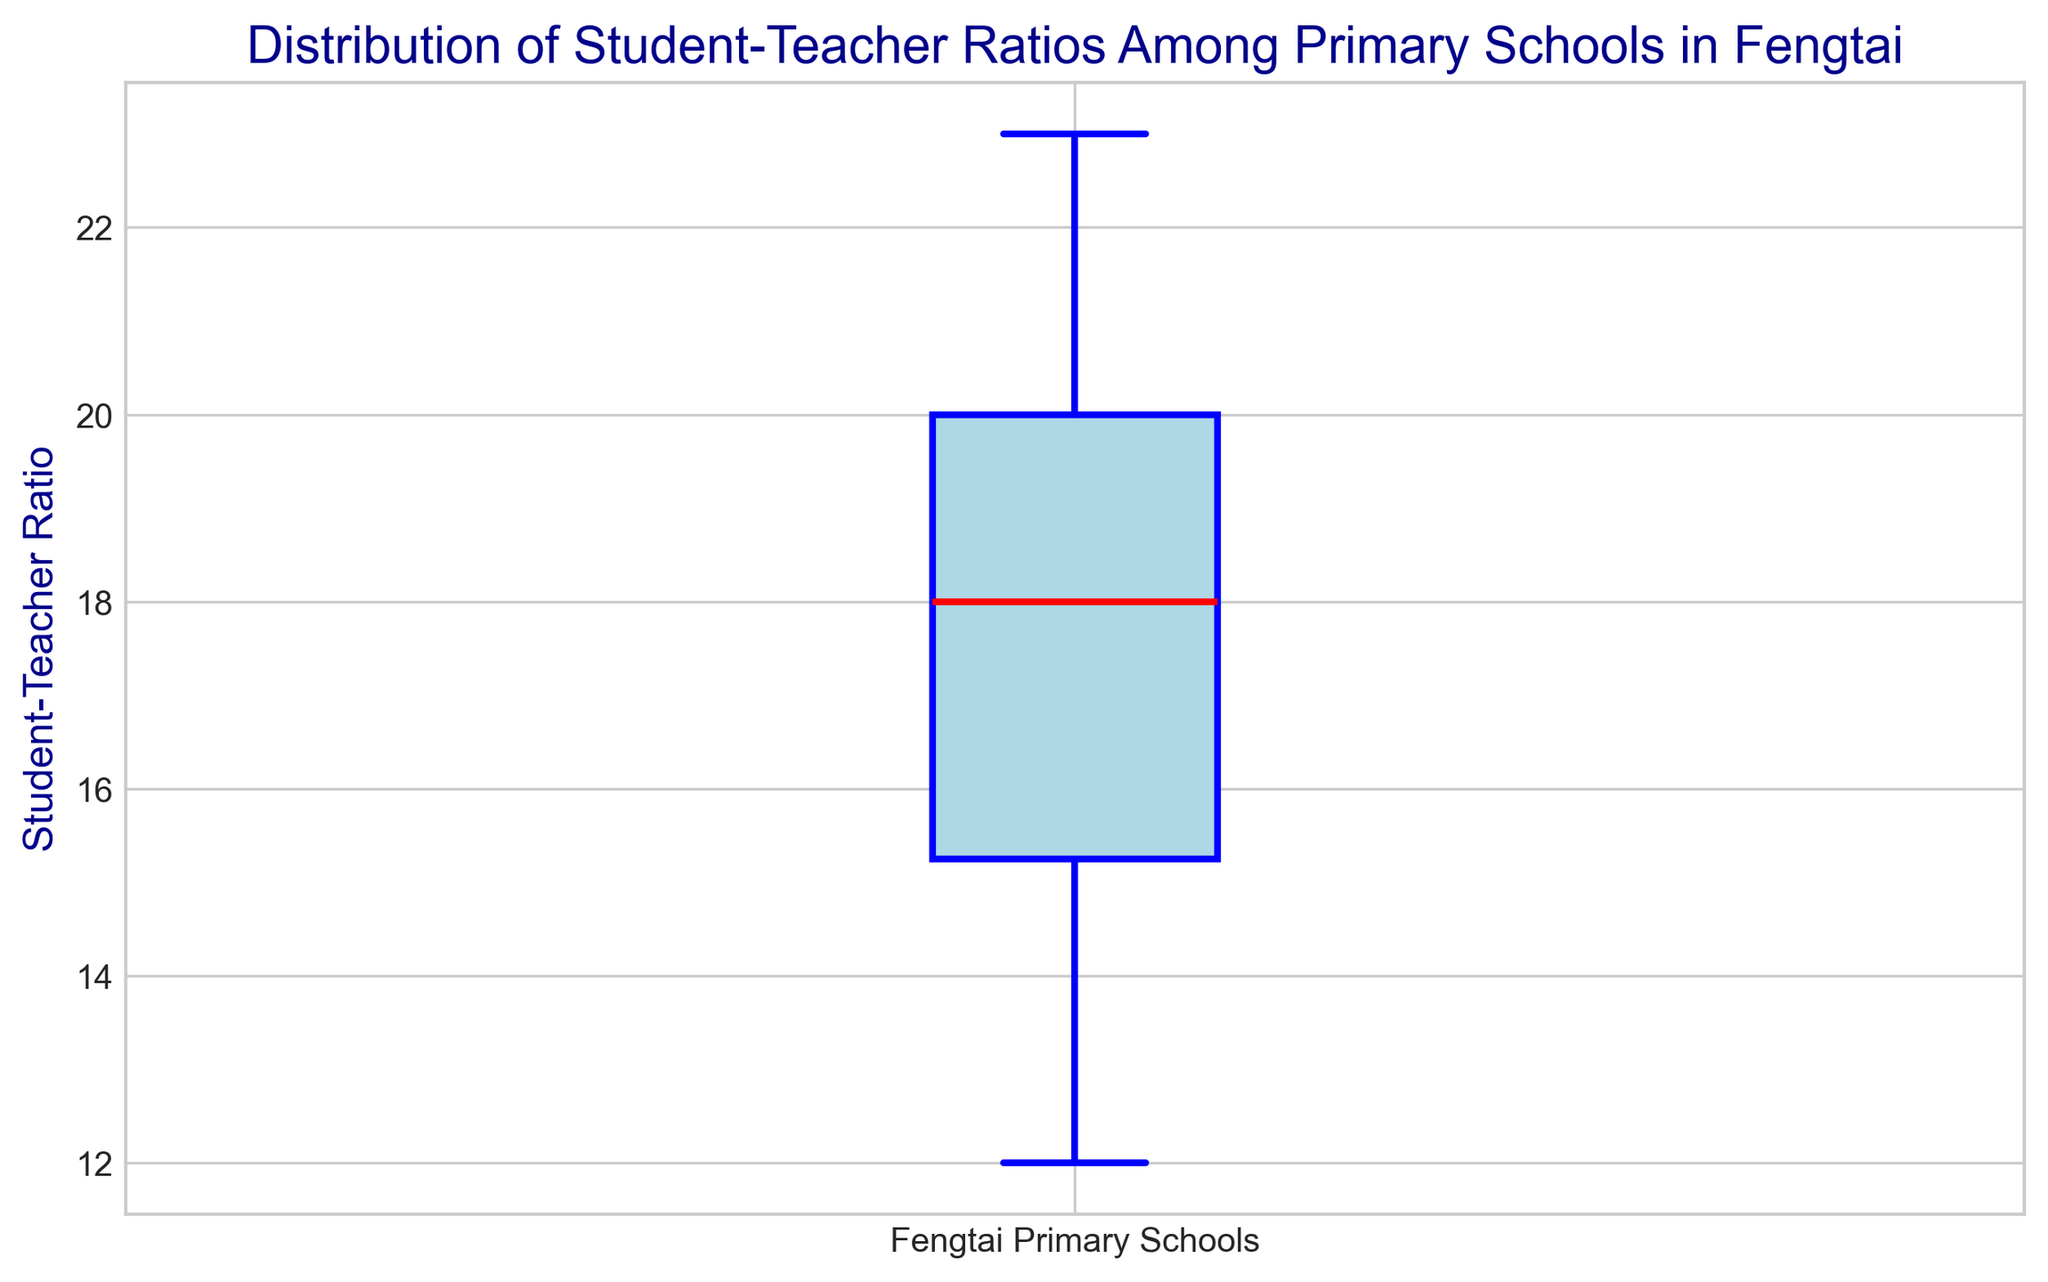What is the median student-teacher ratio in Fengtai primary schools according to the box plot? To find the median, locate the middle line of the box plot, which represents the median student-teacher ratio.
Answer: 18 What is the interquartile range (IQR) of the student-teacher ratios? The IQR is the difference between the third quartile (Q3) and the first quartile (Q1). From the box plot, Q3 is at 20 and Q1 is at 15. Thus, IQR = Q3 - Q1 = 20 - 15.
Answer: 5 What can you deduce about the spread of student-teacher ratios based on the length of the box? The length of the box represents the IQR, indicating the spread of the middle 50% of data. A longer box signifies a wider spread and more variability in the middle half of the student-teacher ratios.
Answer: Wide spread Which value(s) might be considered outliers in this distribution? Outliers are points that lie beyond the whiskers of the box plot. From the box plot, observe the points marked outside the whiskers, which are usually indicated by dots.
Answer: None visible Compare the median student-teacher ratio to the upper whisker. Is the upper whisker value higher than the median? Locate both the median (middle line within the box) and the upper whisker (top extent of the whiskers) on the box plot. The upper whisker value is higher than the median if it lies above the median's position.
Answer: Yes How can you identify the minimum student-teacher ratio in the distribution? The minimum student-teacher ratio corresponds to the bottom whisker of the box plot. Locate the bottom end of the whisker on the plot to find this value.
Answer: 12 Determine the range of student-teacher ratios shown in the box plot. The range is the difference between the maximum and minimum values. From the plot, the maximum (top whisker) is 23, and the minimum (bottom whisker) is 12. So, range = 23 - 12.
Answer: 11 How does the median student-teacher ratio compare to the first quartile? Check the position of the median line and compare it to the lower edge of the box (first quartile). The median is higher than the first quartile if it is located above the lower edge of the box.
Answer: Median is higher What does the color blue represent in the box plot? The color blue is used for several elements in this box plot: the box itself, the whiskers, and the caps, indicating these key parts of the distribution.
Answer: Main parts of the box plot What does the red line in the box plot signify? The red line in the box plot represents the median student-teacher ratio among the primary schools in Fengtai.
Answer: Median 